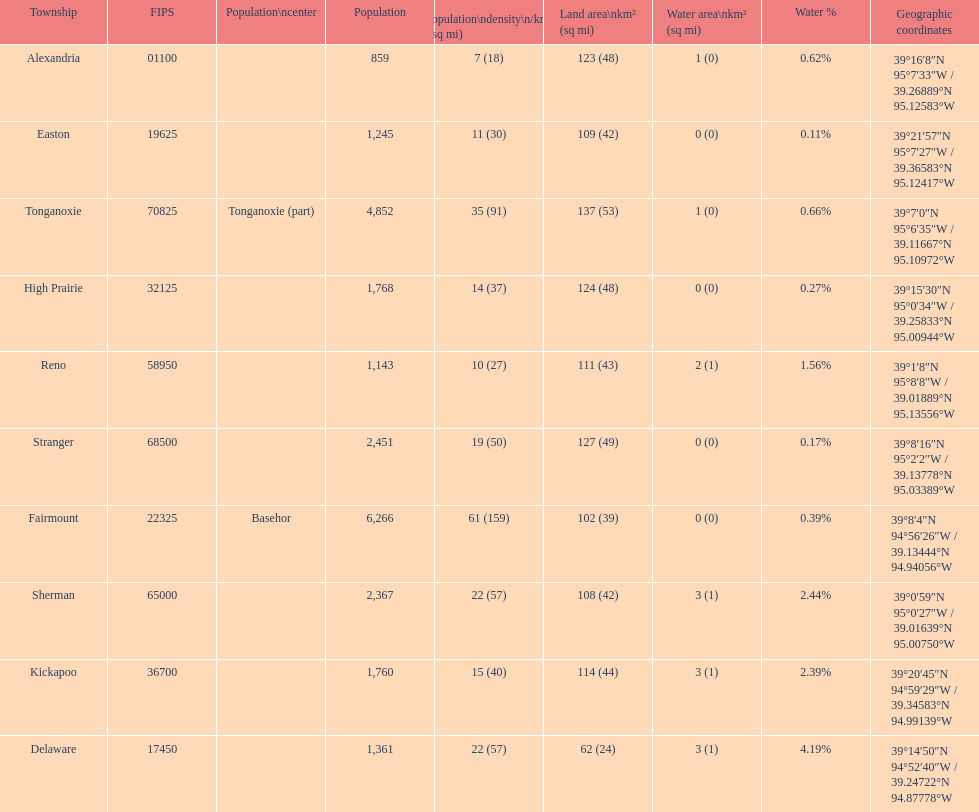What is the number of townships with a population larger than 2,000? 4. 